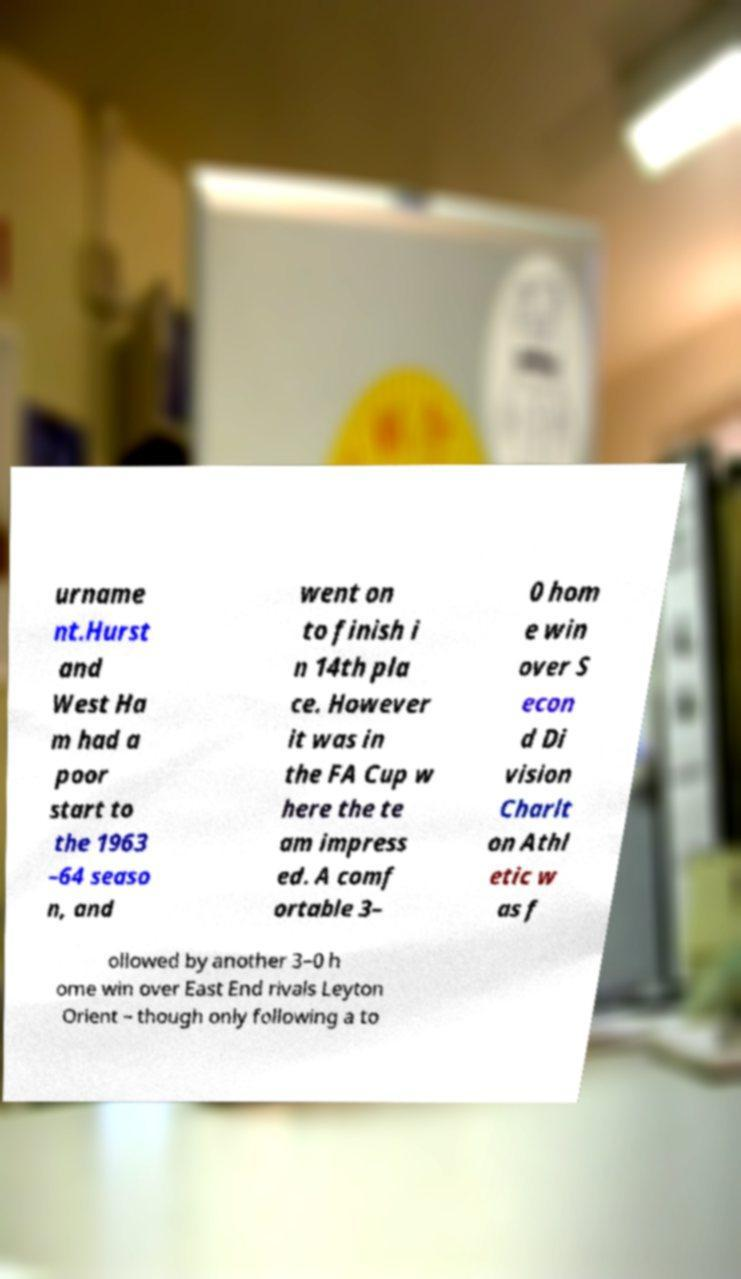What messages or text are displayed in this image? I need them in a readable, typed format. urname nt.Hurst and West Ha m had a poor start to the 1963 –64 seaso n, and went on to finish i n 14th pla ce. However it was in the FA Cup w here the te am impress ed. A comf ortable 3– 0 hom e win over S econ d Di vision Charlt on Athl etic w as f ollowed by another 3–0 h ome win over East End rivals Leyton Orient – though only following a to 